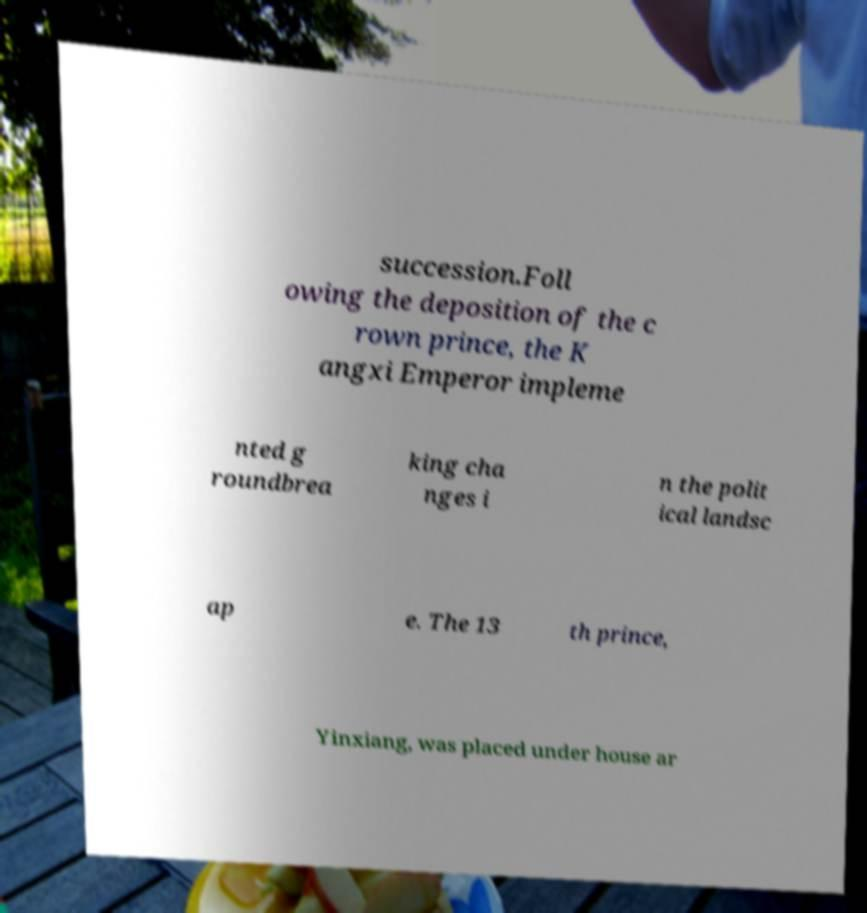For documentation purposes, I need the text within this image transcribed. Could you provide that? succession.Foll owing the deposition of the c rown prince, the K angxi Emperor impleme nted g roundbrea king cha nges i n the polit ical landsc ap e. The 13 th prince, Yinxiang, was placed under house ar 